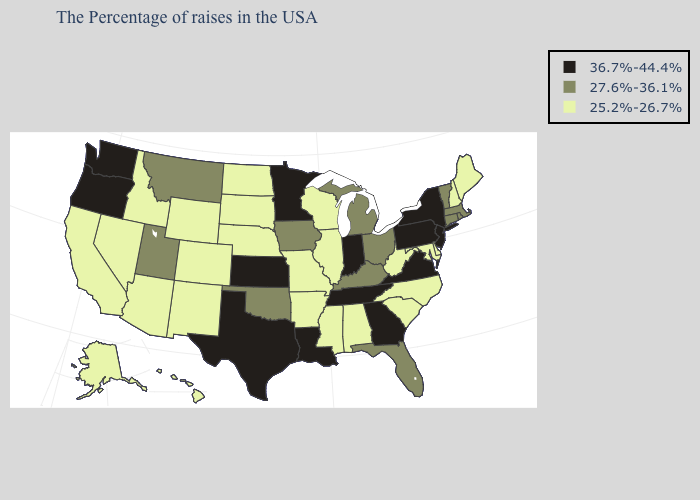Among the states that border New York , does Vermont have the lowest value?
Be succinct. Yes. Which states have the lowest value in the USA?
Be succinct. Maine, New Hampshire, Delaware, Maryland, North Carolina, South Carolina, West Virginia, Alabama, Wisconsin, Illinois, Mississippi, Missouri, Arkansas, Nebraska, South Dakota, North Dakota, Wyoming, Colorado, New Mexico, Arizona, Idaho, Nevada, California, Alaska, Hawaii. Which states have the lowest value in the USA?
Concise answer only. Maine, New Hampshire, Delaware, Maryland, North Carolina, South Carolina, West Virginia, Alabama, Wisconsin, Illinois, Mississippi, Missouri, Arkansas, Nebraska, South Dakota, North Dakota, Wyoming, Colorado, New Mexico, Arizona, Idaho, Nevada, California, Alaska, Hawaii. Among the states that border Ohio , does Pennsylvania have the lowest value?
Concise answer only. No. Name the states that have a value in the range 25.2%-26.7%?
Keep it brief. Maine, New Hampshire, Delaware, Maryland, North Carolina, South Carolina, West Virginia, Alabama, Wisconsin, Illinois, Mississippi, Missouri, Arkansas, Nebraska, South Dakota, North Dakota, Wyoming, Colorado, New Mexico, Arizona, Idaho, Nevada, California, Alaska, Hawaii. Does Iowa have a higher value than Pennsylvania?
Give a very brief answer. No. Does Alaska have the highest value in the West?
Short answer required. No. What is the value of New York?
Short answer required. 36.7%-44.4%. What is the value of Missouri?
Be succinct. 25.2%-26.7%. Name the states that have a value in the range 27.6%-36.1%?
Give a very brief answer. Massachusetts, Rhode Island, Vermont, Connecticut, Ohio, Florida, Michigan, Kentucky, Iowa, Oklahoma, Utah, Montana. How many symbols are there in the legend?
Short answer required. 3. Name the states that have a value in the range 36.7%-44.4%?
Short answer required. New York, New Jersey, Pennsylvania, Virginia, Georgia, Indiana, Tennessee, Louisiana, Minnesota, Kansas, Texas, Washington, Oregon. How many symbols are there in the legend?
Short answer required. 3. Name the states that have a value in the range 25.2%-26.7%?
Write a very short answer. Maine, New Hampshire, Delaware, Maryland, North Carolina, South Carolina, West Virginia, Alabama, Wisconsin, Illinois, Mississippi, Missouri, Arkansas, Nebraska, South Dakota, North Dakota, Wyoming, Colorado, New Mexico, Arizona, Idaho, Nevada, California, Alaska, Hawaii. Does Washington have the highest value in the USA?
Concise answer only. Yes. 